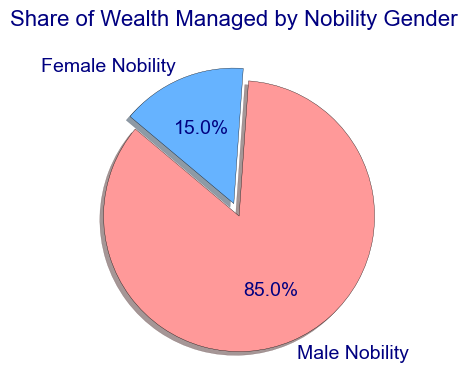Which gender manages a greater share of wealth? The pie chart shows that "Male Nobility" has 85% while "Female Nobility" has 15%. Thus, Male Nobility manages a greater share of wealth.
Answer: Male Nobility What's the exact percentage of wealth managed by Female Nobility? In the pie chart, the slice labeled "Female Nobility" shows 15%, indicating the percentage of wealth they manage.
Answer: 15% How much more wealth, in percentage points, is managed by Male Nobility compared to Female Nobility? Male Nobility manages 85%, and Female Nobility manages 15%. To find the difference: 85% - 15% = 70%.
Answer: 70% If the total wealth was 100 million livres, how much wealth in livres is managed by Female Nobility? Female Nobility manages 15% of the total wealth. So, calculate 15% of 100 million livres: (15/100) * 100,000,000 = 15,000,000 livres.
Answer: 15 million livres What fraction of the total wealth is managed by Female Nobility? The share managed by Female Nobility is 15%, which translates to the fraction 15/100 or simplified, 3/20.
Answer: 3/20 Which slice of the pie chart is exploded and why might it be highlighted this way? The slice for Female Nobility is exploded. It might be highlighted to draw attention to the relatively smaller share of wealth managed by females compared to males.
Answer: Female Nobility What is the visual implication of the color choice for the pie chart slices? The pie chart uses red for Female Nobility and blue for Male Nobility. The contrasting colors help viewers easily distinguish the two slices.
Answer: To distinguish gender What is the angle in degrees of the pie slice representing Female Nobility? Since Female Nobility manages 15% of the wealth, the angle can be calculated as (15/100) * 360° = 54°.
Answer: 54° Given that the pie chart starts at a 140° angle, at what angle does the slice for Male Nobility end? Male Nobility starts immediately after the 54° slice for Female Nobility and manages 85% of the wealth. The angle for Male Nobility would therefore be 54° + (85/100) * 360° = 360°. Starting from 140°, the ending angle would be 140° + 360° - 140° = 360°.
Answer: 360° Is the size of any slice shadowed or highlighted differently? If so, which one and what purpose might this serve? The pie chart indicates a shadow effect and an explosion on the Female Nobility slice, likely to emphasize their portion of wealth for better visibility and interpretation.
Answer: Female Nobility 